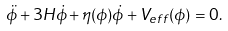<formula> <loc_0><loc_0><loc_500><loc_500>\ddot { \phi } + 3 H \dot { \phi } + \eta ( \phi ) \dot { \phi } + V _ { e f f } ( \phi ) = 0 .</formula> 